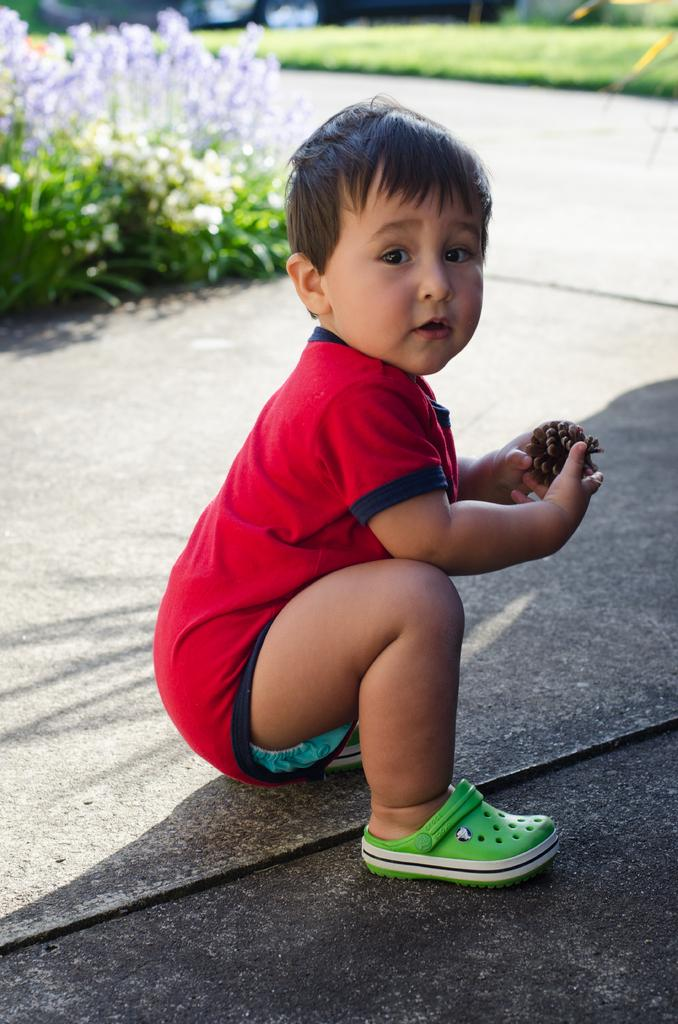What is the main subject of the image? There is a boy in the center of the image. What is the boy wearing? The boy is wearing a red t-shirt. Where is the boy located in the image? The boy is on the road. What is the boy holding in the image? The boy is holding an object. What can be seen in the background of the image? There are flower plants in the background of the image. What type of vegetation is visible in the image? Grass is visible in the image. What type of bath can be seen in the image? There is no bath present in the image; it features a boy on the road. What activity is the boy participating in during recess? The image does not depict a recess or any specific activity the boy might be engaged in. 